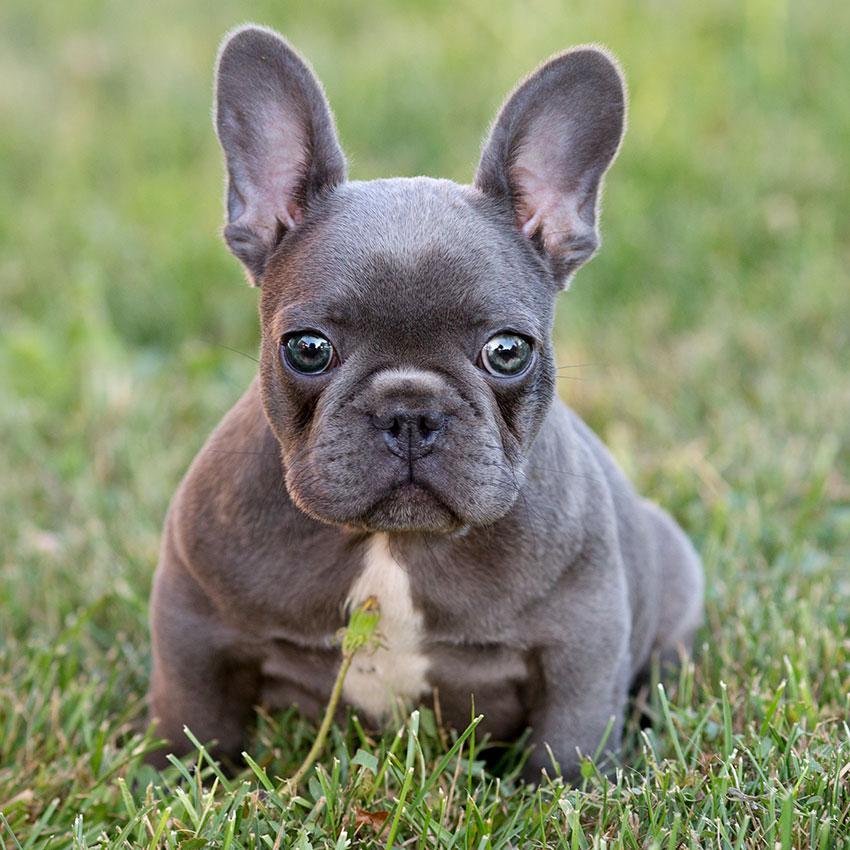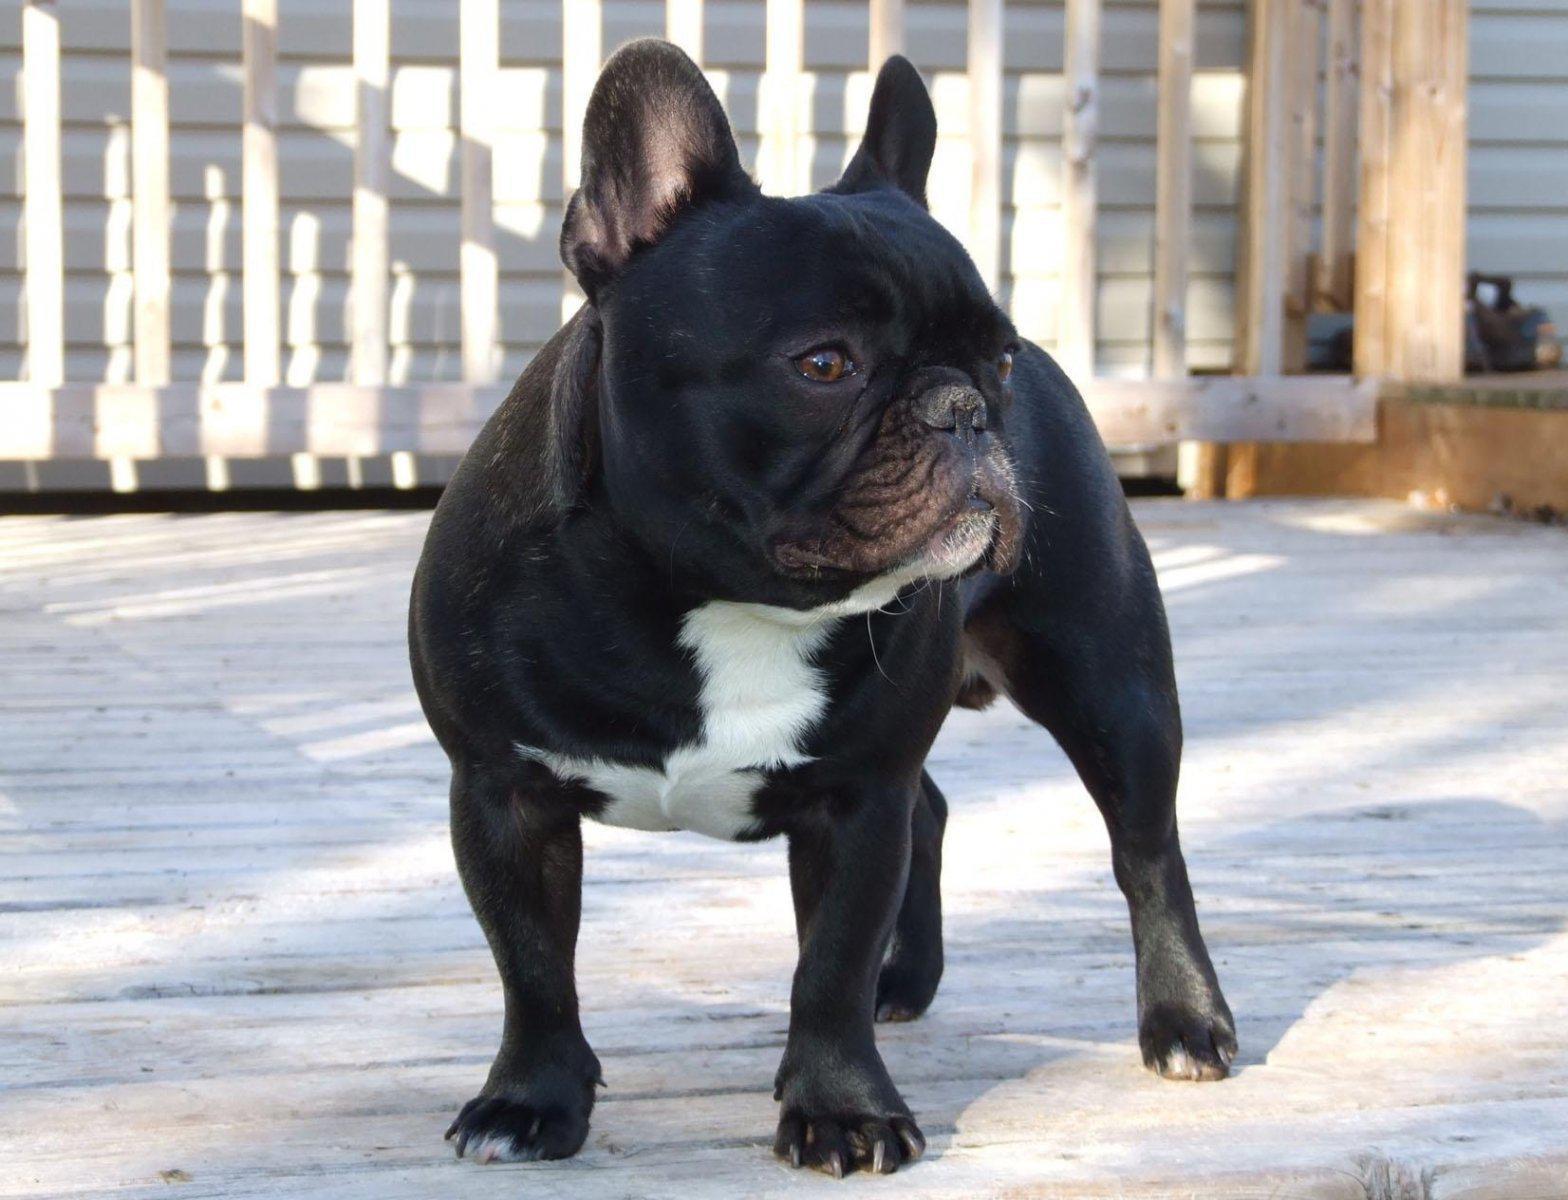The first image is the image on the left, the second image is the image on the right. Assess this claim about the two images: "A total of three puppies are shown, most of them sitting.". Correct or not? Answer yes or no. No. The first image is the image on the left, the second image is the image on the right. Analyze the images presented: Is the assertion "There are exactly three puppies." valid? Answer yes or no. No. 